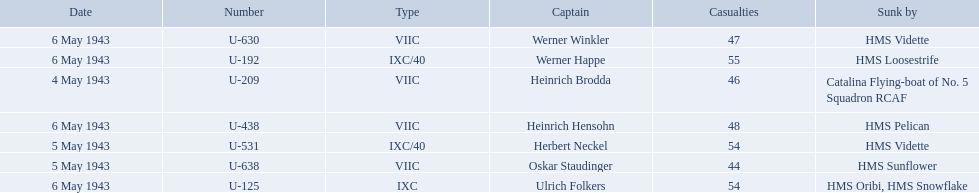Which were the names of the sinkers of the convoys? Catalina Flying-boat of No. 5 Squadron RCAF, HMS Sunflower, HMS Vidette, HMS Loosestrife, HMS Oribi, HMS Snowflake, HMS Vidette, HMS Pelican. What captain was sunk by the hms pelican? Heinrich Hensohn. What is the list of ships under sunk by? Catalina Flying-boat of No. 5 Squadron RCAF, HMS Sunflower, HMS Vidette, HMS Loosestrife, HMS Oribi, HMS Snowflake, HMS Vidette, HMS Pelican. Which captains did hms pelican sink? Heinrich Hensohn. 